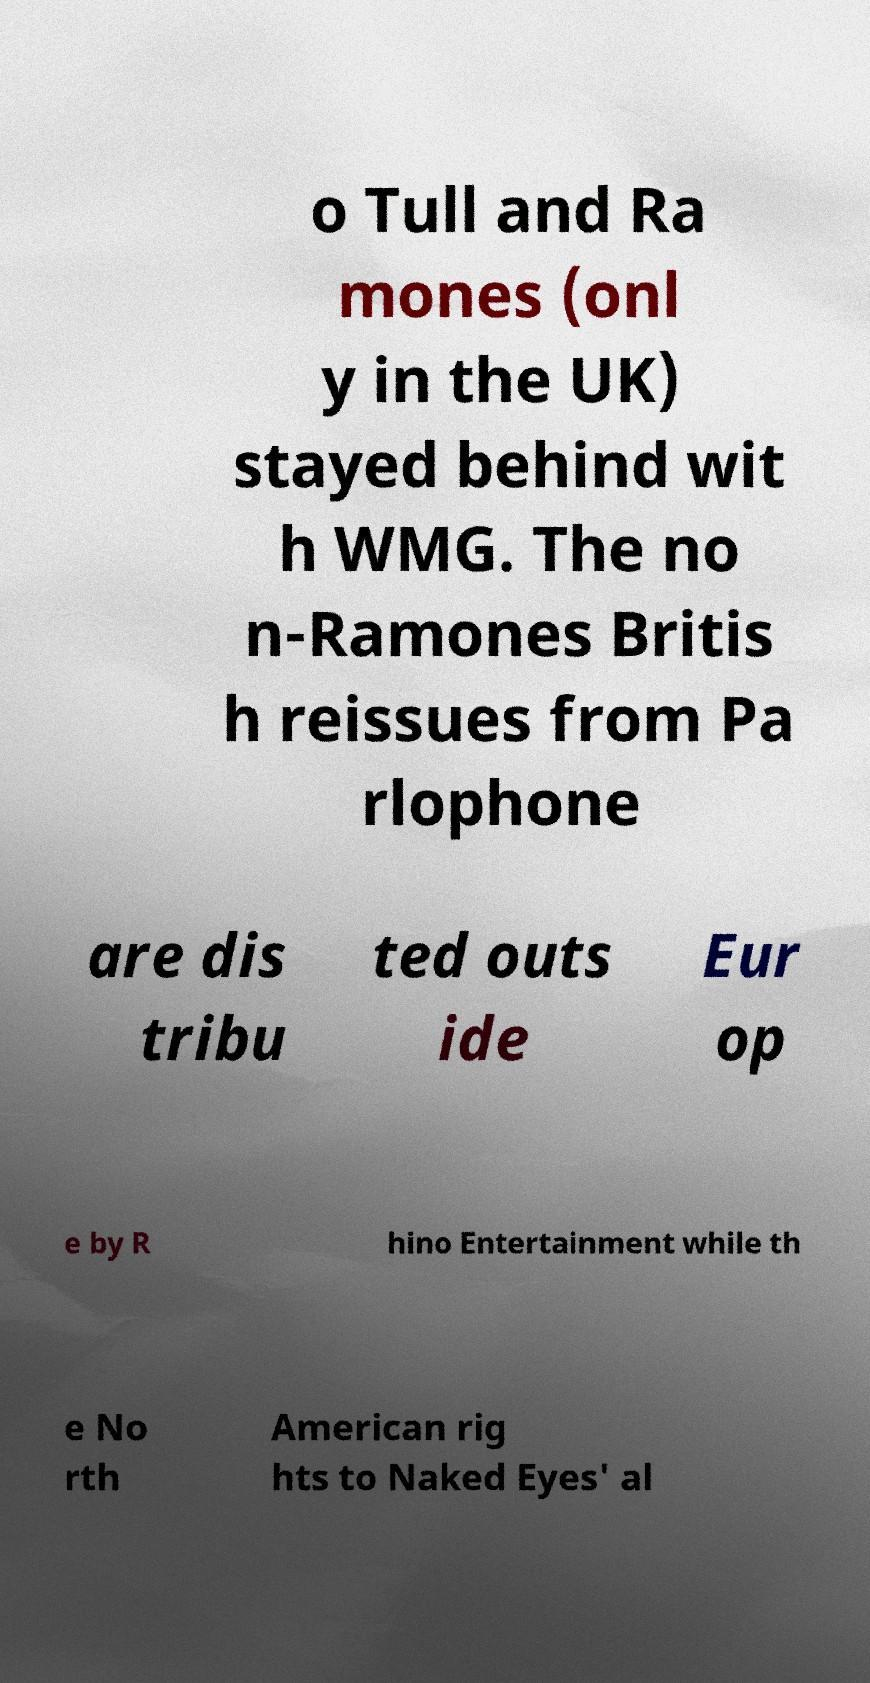Please read and relay the text visible in this image. What does it say? o Tull and Ra mones (onl y in the UK) stayed behind wit h WMG. The no n-Ramones Britis h reissues from Pa rlophone are dis tribu ted outs ide Eur op e by R hino Entertainment while th e No rth American rig hts to Naked Eyes' al 